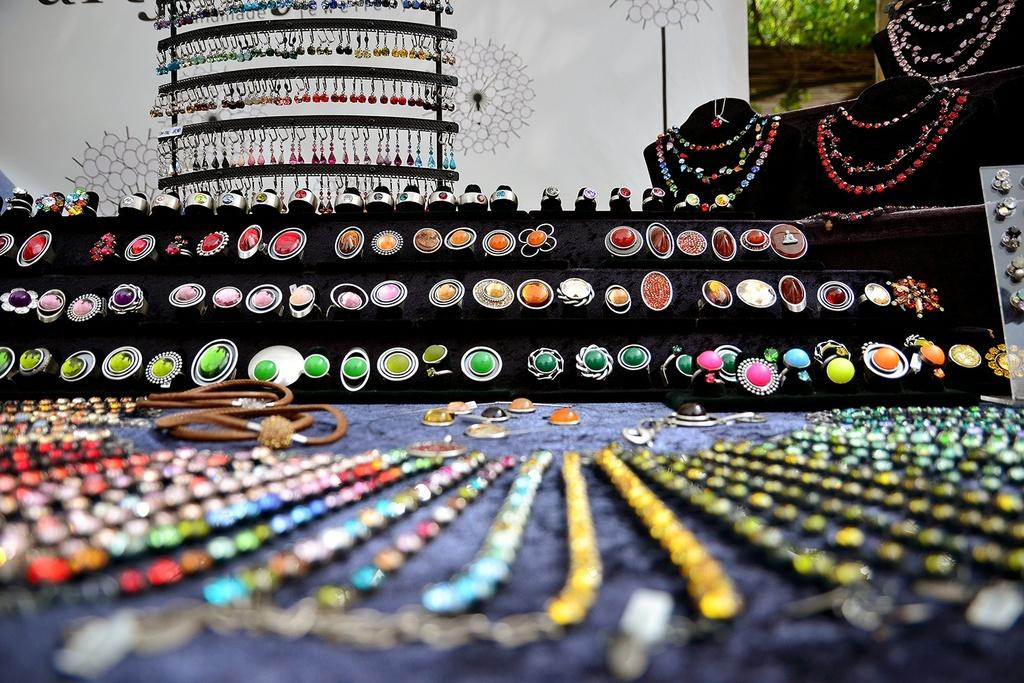What types of decorative items can be seen in the image? There are ornaments in the image. Can you describe the background of the image? There are objects in the background of the image. What type of pump is being used to inflate the ornaments in the image? There is no pump present in the image, and the ornaments do not require inflation. 